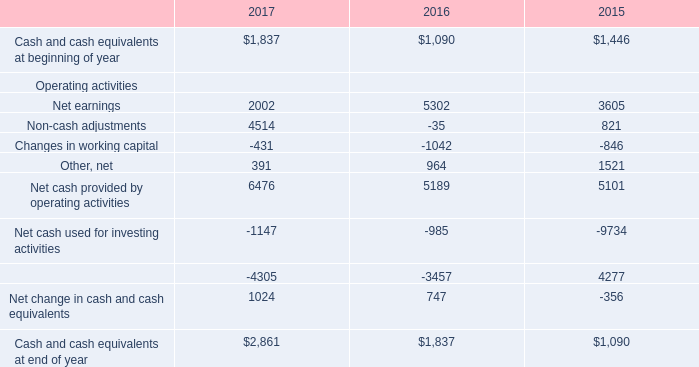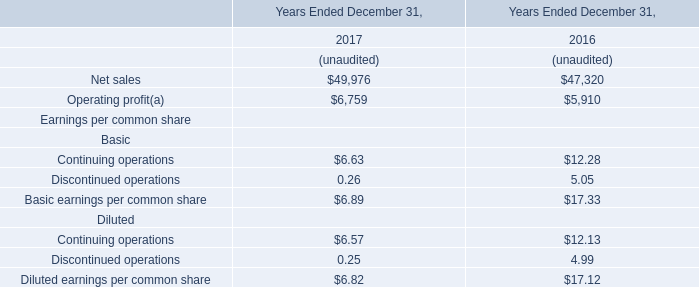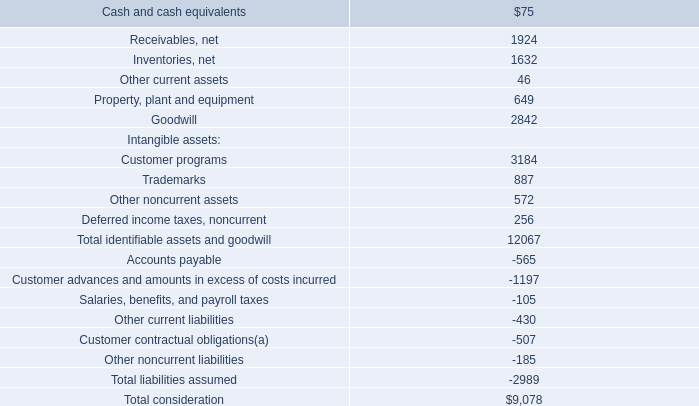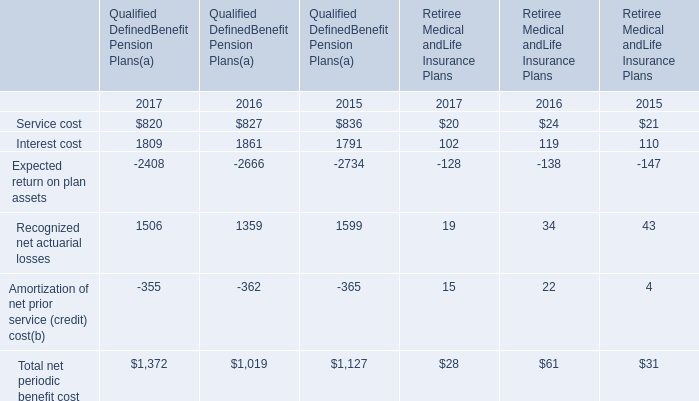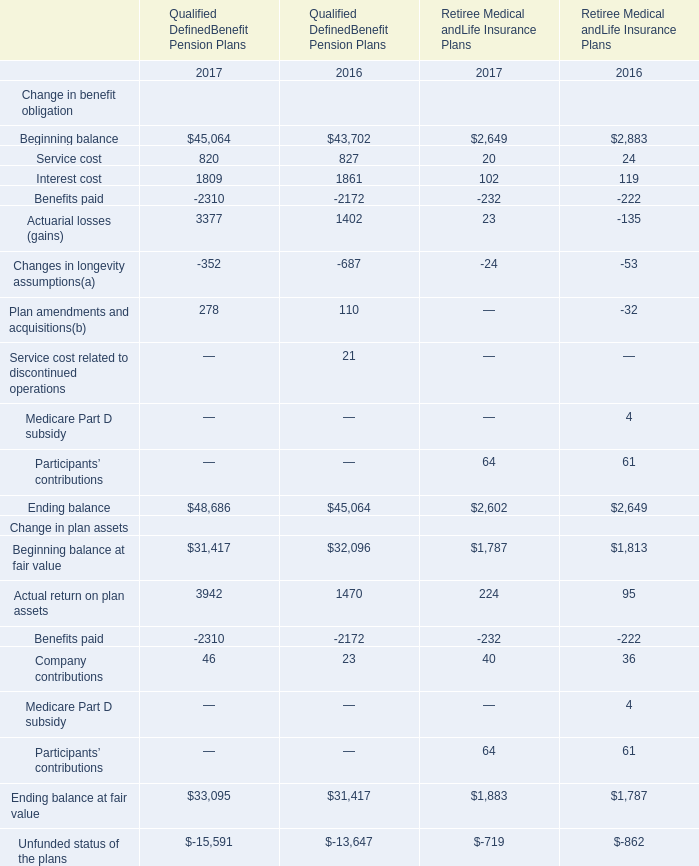What is the percentage of all Interest cost that are positive to the total amount, in 2017? 
Computations: (1809 / (((((820 + 1809) - 2408) + 1506) - 355) + 1372))
Answer: 0.65926. 